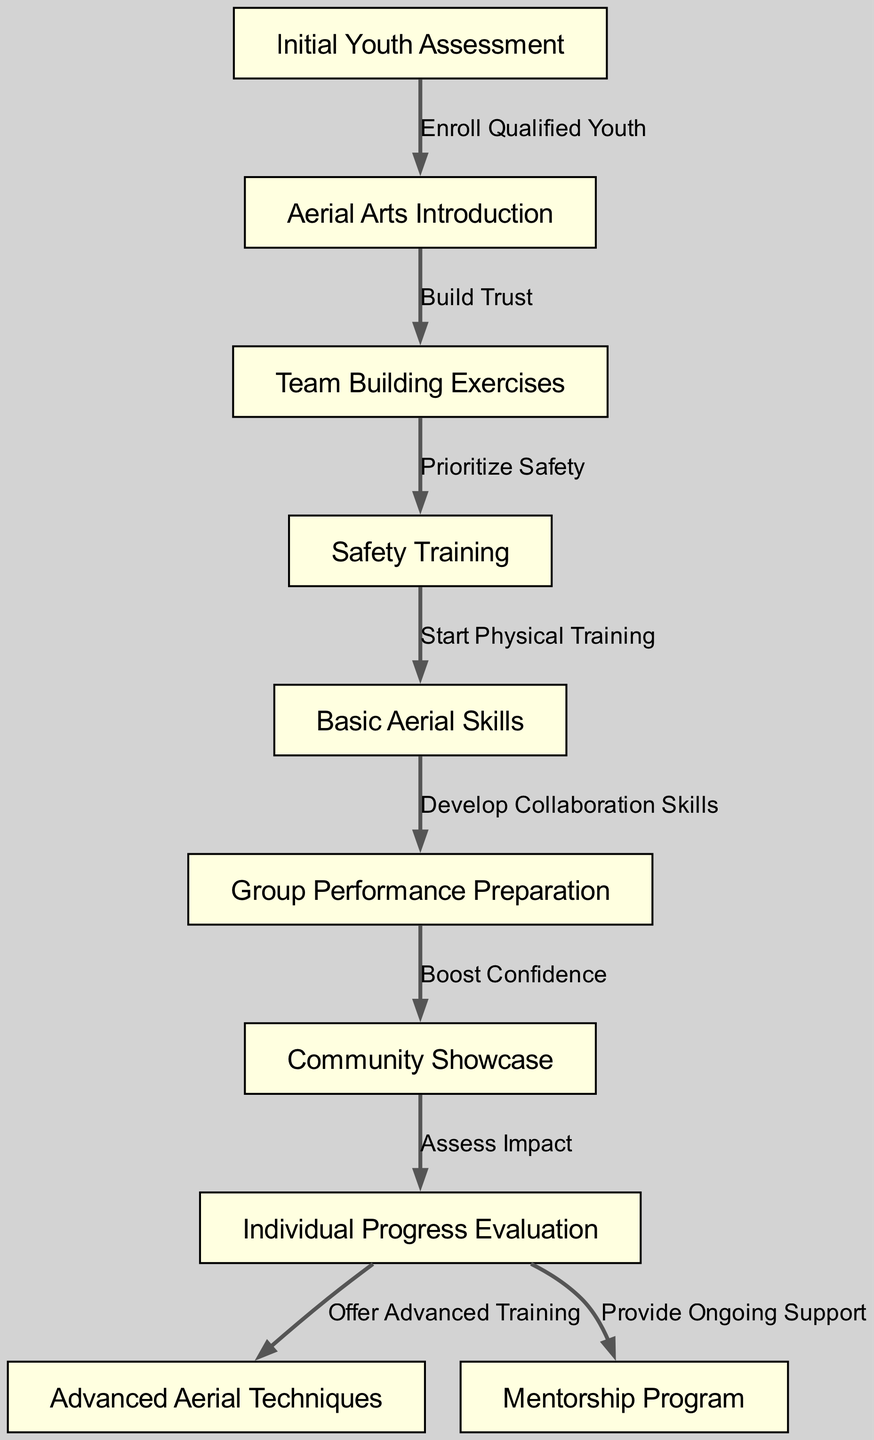What is the first step in the clinical pathway? The diagram starts with the node labeled "Initial Youth Assessment," which indicates that this is the first step in the pathway.
Answer: Initial Youth Assessment How many nodes are present in the clinical pathway? By counting the distinct nodes listed in the diagram, we find there are ten nodes in total.
Answer: Ten What connects "Safety Training" and "Basic Aerial Skills"? The edge labeled "Start Physical Training" indicates the connection between "Safety Training" and "Basic Aerial Skills."
Answer: Start Physical Training What is the last step before the "Community Showcase"? The diagram shows that "Group Performance Preparation" is the step that directly precedes the "Community Showcase."
Answer: Group Performance Preparation Which node offers ongoing support after individual evaluation? The "Provide Ongoing Support" edge from the "Individual Progress Evaluation" node indicates that this is the node that provides ongoing support.
Answer: Provide Ongoing Support What is the relationship between "Basic Aerial Skills" and "Advanced Aerial Techniques"? The diagram indicates that "Basic Aerial Skills" leads into "Advanced Aerial Techniques" through the node "Offer Advanced Training."
Answer: Offer Advanced Training How many edges are present in the clinical pathway? By counting the edges connecting the nodes, we determine there are nine edges within the diagram.
Answer: Nine Which node focuses on building trust among participants? "Team Building Exercises" is the node specifically focused on building trust as indicated by its direct connections and purpose in the diagram.
Answer: Team Building Exercises What is the purpose of "Aerial Arts Introduction"? This node is described in the pathway as the initial enrollment step for qualified youth, emphasizing its role in introducing the aerial arts.
Answer: Enroll Qualified Youth 